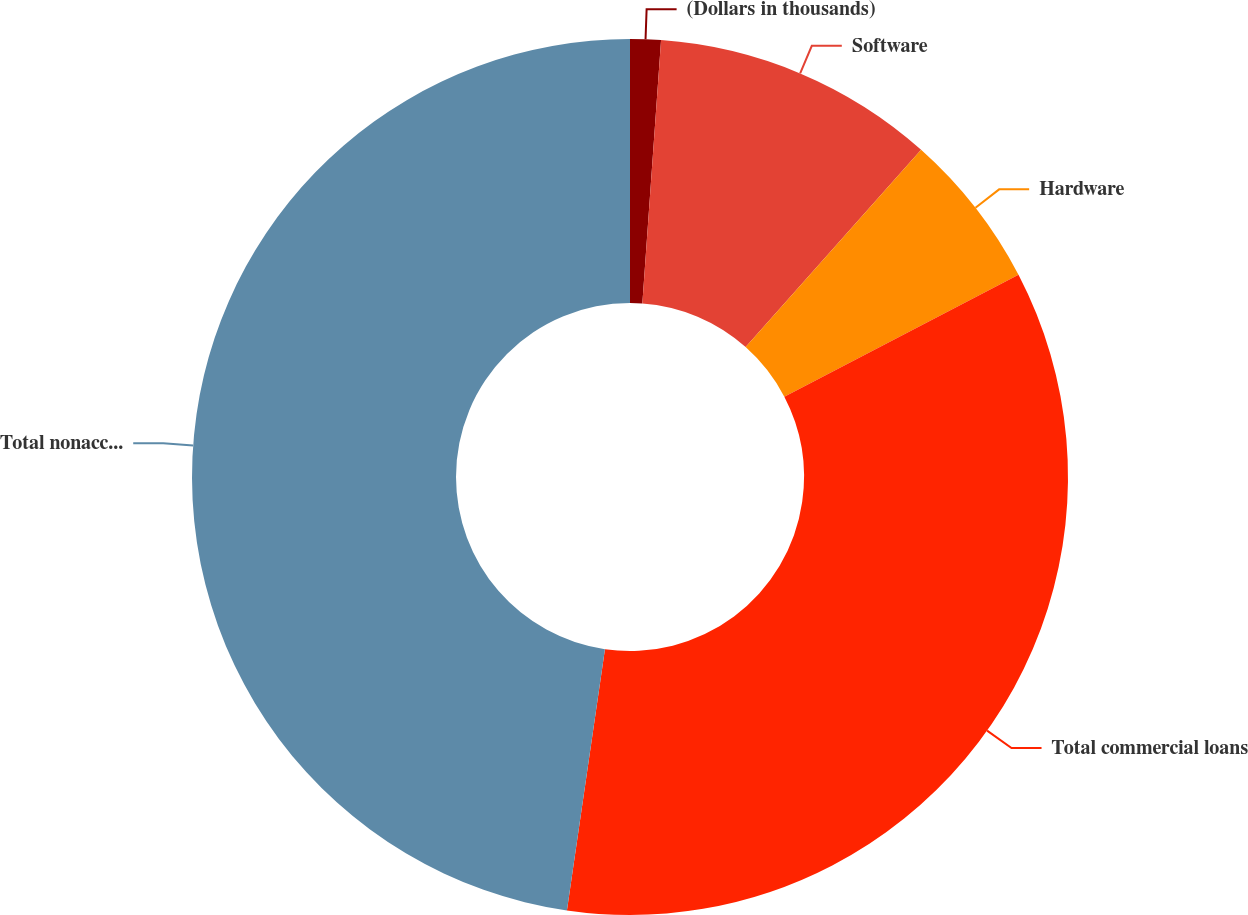Convert chart. <chart><loc_0><loc_0><loc_500><loc_500><pie_chart><fcel>(Dollars in thousands)<fcel>Software<fcel>Hardware<fcel>Total commercial loans<fcel>Total nonaccrual loans<nl><fcel>1.13%<fcel>10.44%<fcel>5.79%<fcel>34.94%<fcel>47.7%<nl></chart> 